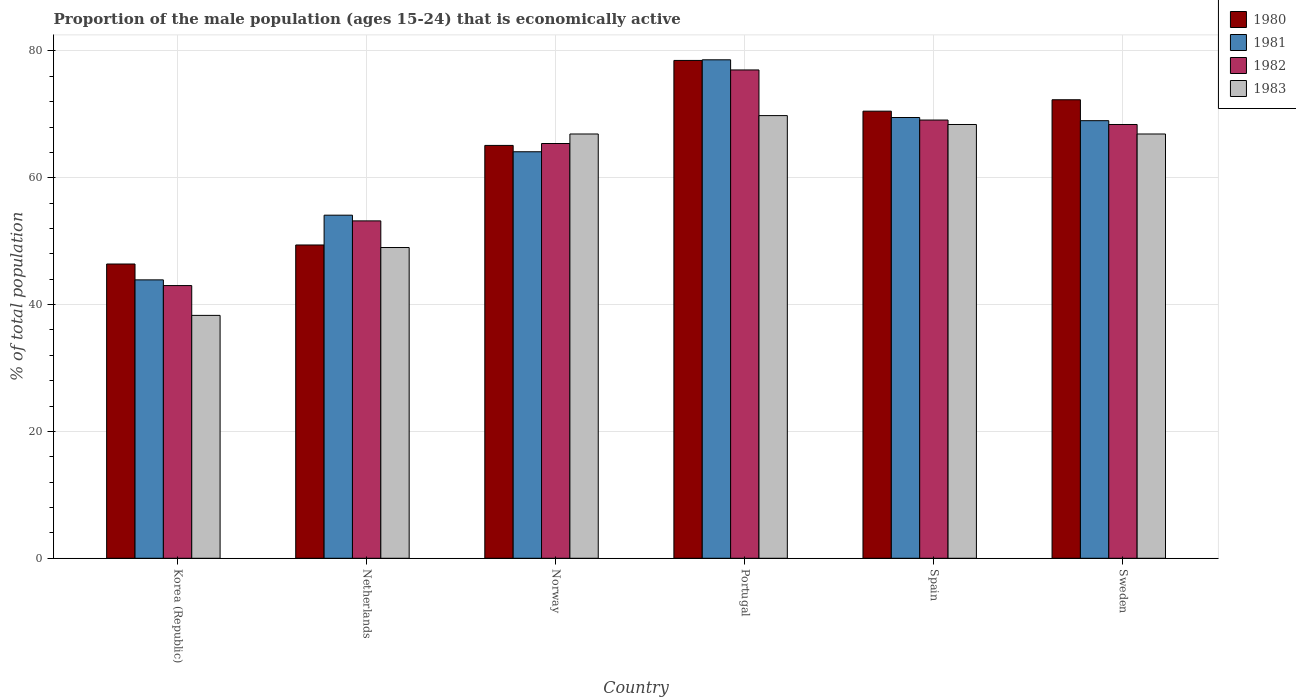How many different coloured bars are there?
Your response must be concise. 4. Are the number of bars on each tick of the X-axis equal?
Ensure brevity in your answer.  Yes. How many bars are there on the 5th tick from the left?
Provide a succinct answer. 4. How many bars are there on the 2nd tick from the right?
Offer a terse response. 4. What is the label of the 5th group of bars from the left?
Your answer should be very brief. Spain. What is the proportion of the male population that is economically active in 1983 in Norway?
Your answer should be compact. 66.9. Across all countries, what is the maximum proportion of the male population that is economically active in 1981?
Provide a short and direct response. 78.6. Across all countries, what is the minimum proportion of the male population that is economically active in 1980?
Offer a very short reply. 46.4. What is the total proportion of the male population that is economically active in 1982 in the graph?
Provide a succinct answer. 376.1. What is the difference between the proportion of the male population that is economically active in 1982 in Spain and that in Sweden?
Offer a very short reply. 0.7. What is the average proportion of the male population that is economically active in 1980 per country?
Your response must be concise. 63.7. What is the difference between the proportion of the male population that is economically active of/in 1981 and proportion of the male population that is economically active of/in 1982 in Portugal?
Provide a short and direct response. 1.6. What is the ratio of the proportion of the male population that is economically active in 1980 in Netherlands to that in Norway?
Your answer should be very brief. 0.76. What is the difference between the highest and the second highest proportion of the male population that is economically active in 1980?
Offer a terse response. 1.8. What is the difference between the highest and the lowest proportion of the male population that is economically active in 1982?
Your answer should be compact. 34. Is the sum of the proportion of the male population that is economically active in 1980 in Netherlands and Spain greater than the maximum proportion of the male population that is economically active in 1983 across all countries?
Keep it short and to the point. Yes. Is it the case that in every country, the sum of the proportion of the male population that is economically active in 1980 and proportion of the male population that is economically active in 1982 is greater than the sum of proportion of the male population that is economically active in 1983 and proportion of the male population that is economically active in 1981?
Make the answer very short. No. What does the 4th bar from the right in Portugal represents?
Ensure brevity in your answer.  1980. Is it the case that in every country, the sum of the proportion of the male population that is economically active in 1983 and proportion of the male population that is economically active in 1981 is greater than the proportion of the male population that is economically active in 1980?
Your answer should be very brief. Yes. How many bars are there?
Your answer should be very brief. 24. Are all the bars in the graph horizontal?
Keep it short and to the point. No. How many countries are there in the graph?
Give a very brief answer. 6. What is the difference between two consecutive major ticks on the Y-axis?
Your response must be concise. 20. What is the title of the graph?
Give a very brief answer. Proportion of the male population (ages 15-24) that is economically active. What is the label or title of the X-axis?
Make the answer very short. Country. What is the label or title of the Y-axis?
Provide a succinct answer. % of total population. What is the % of total population of 1980 in Korea (Republic)?
Offer a very short reply. 46.4. What is the % of total population of 1981 in Korea (Republic)?
Ensure brevity in your answer.  43.9. What is the % of total population of 1983 in Korea (Republic)?
Make the answer very short. 38.3. What is the % of total population of 1980 in Netherlands?
Provide a short and direct response. 49.4. What is the % of total population of 1981 in Netherlands?
Make the answer very short. 54.1. What is the % of total population of 1982 in Netherlands?
Your response must be concise. 53.2. What is the % of total population in 1980 in Norway?
Ensure brevity in your answer.  65.1. What is the % of total population of 1981 in Norway?
Your response must be concise. 64.1. What is the % of total population in 1982 in Norway?
Your answer should be very brief. 65.4. What is the % of total population in 1983 in Norway?
Provide a short and direct response. 66.9. What is the % of total population of 1980 in Portugal?
Keep it short and to the point. 78.5. What is the % of total population of 1981 in Portugal?
Offer a terse response. 78.6. What is the % of total population of 1983 in Portugal?
Make the answer very short. 69.8. What is the % of total population of 1980 in Spain?
Give a very brief answer. 70.5. What is the % of total population in 1981 in Spain?
Ensure brevity in your answer.  69.5. What is the % of total population of 1982 in Spain?
Your answer should be compact. 69.1. What is the % of total population in 1983 in Spain?
Offer a terse response. 68.4. What is the % of total population in 1980 in Sweden?
Provide a succinct answer. 72.3. What is the % of total population of 1981 in Sweden?
Give a very brief answer. 69. What is the % of total population of 1982 in Sweden?
Offer a terse response. 68.4. What is the % of total population of 1983 in Sweden?
Offer a terse response. 66.9. Across all countries, what is the maximum % of total population in 1980?
Ensure brevity in your answer.  78.5. Across all countries, what is the maximum % of total population in 1981?
Keep it short and to the point. 78.6. Across all countries, what is the maximum % of total population of 1982?
Keep it short and to the point. 77. Across all countries, what is the maximum % of total population in 1983?
Offer a very short reply. 69.8. Across all countries, what is the minimum % of total population in 1980?
Keep it short and to the point. 46.4. Across all countries, what is the minimum % of total population of 1981?
Your response must be concise. 43.9. Across all countries, what is the minimum % of total population of 1982?
Your response must be concise. 43. Across all countries, what is the minimum % of total population of 1983?
Provide a short and direct response. 38.3. What is the total % of total population of 1980 in the graph?
Give a very brief answer. 382.2. What is the total % of total population of 1981 in the graph?
Offer a terse response. 379.2. What is the total % of total population in 1982 in the graph?
Your answer should be very brief. 376.1. What is the total % of total population of 1983 in the graph?
Provide a succinct answer. 359.3. What is the difference between the % of total population in 1980 in Korea (Republic) and that in Netherlands?
Give a very brief answer. -3. What is the difference between the % of total population in 1981 in Korea (Republic) and that in Netherlands?
Give a very brief answer. -10.2. What is the difference between the % of total population of 1983 in Korea (Republic) and that in Netherlands?
Provide a succinct answer. -10.7. What is the difference between the % of total population of 1980 in Korea (Republic) and that in Norway?
Provide a succinct answer. -18.7. What is the difference between the % of total population in 1981 in Korea (Republic) and that in Norway?
Provide a short and direct response. -20.2. What is the difference between the % of total population in 1982 in Korea (Republic) and that in Norway?
Your answer should be very brief. -22.4. What is the difference between the % of total population of 1983 in Korea (Republic) and that in Norway?
Provide a short and direct response. -28.6. What is the difference between the % of total population of 1980 in Korea (Republic) and that in Portugal?
Your answer should be compact. -32.1. What is the difference between the % of total population of 1981 in Korea (Republic) and that in Portugal?
Offer a terse response. -34.7. What is the difference between the % of total population of 1982 in Korea (Republic) and that in Portugal?
Ensure brevity in your answer.  -34. What is the difference between the % of total population in 1983 in Korea (Republic) and that in Portugal?
Ensure brevity in your answer.  -31.5. What is the difference between the % of total population in 1980 in Korea (Republic) and that in Spain?
Keep it short and to the point. -24.1. What is the difference between the % of total population of 1981 in Korea (Republic) and that in Spain?
Your response must be concise. -25.6. What is the difference between the % of total population of 1982 in Korea (Republic) and that in Spain?
Your response must be concise. -26.1. What is the difference between the % of total population in 1983 in Korea (Republic) and that in Spain?
Provide a short and direct response. -30.1. What is the difference between the % of total population in 1980 in Korea (Republic) and that in Sweden?
Your response must be concise. -25.9. What is the difference between the % of total population of 1981 in Korea (Republic) and that in Sweden?
Provide a succinct answer. -25.1. What is the difference between the % of total population of 1982 in Korea (Republic) and that in Sweden?
Keep it short and to the point. -25.4. What is the difference between the % of total population of 1983 in Korea (Republic) and that in Sweden?
Your answer should be compact. -28.6. What is the difference between the % of total population in 1980 in Netherlands and that in Norway?
Your answer should be very brief. -15.7. What is the difference between the % of total population in 1981 in Netherlands and that in Norway?
Keep it short and to the point. -10. What is the difference between the % of total population in 1982 in Netherlands and that in Norway?
Offer a terse response. -12.2. What is the difference between the % of total population in 1983 in Netherlands and that in Norway?
Ensure brevity in your answer.  -17.9. What is the difference between the % of total population in 1980 in Netherlands and that in Portugal?
Your response must be concise. -29.1. What is the difference between the % of total population of 1981 in Netherlands and that in Portugal?
Make the answer very short. -24.5. What is the difference between the % of total population in 1982 in Netherlands and that in Portugal?
Make the answer very short. -23.8. What is the difference between the % of total population of 1983 in Netherlands and that in Portugal?
Make the answer very short. -20.8. What is the difference between the % of total population of 1980 in Netherlands and that in Spain?
Keep it short and to the point. -21.1. What is the difference between the % of total population in 1981 in Netherlands and that in Spain?
Offer a very short reply. -15.4. What is the difference between the % of total population in 1982 in Netherlands and that in Spain?
Your answer should be very brief. -15.9. What is the difference between the % of total population in 1983 in Netherlands and that in Spain?
Make the answer very short. -19.4. What is the difference between the % of total population of 1980 in Netherlands and that in Sweden?
Your answer should be very brief. -22.9. What is the difference between the % of total population of 1981 in Netherlands and that in Sweden?
Your response must be concise. -14.9. What is the difference between the % of total population in 1982 in Netherlands and that in Sweden?
Provide a short and direct response. -15.2. What is the difference between the % of total population of 1983 in Netherlands and that in Sweden?
Provide a succinct answer. -17.9. What is the difference between the % of total population in 1981 in Norway and that in Portugal?
Make the answer very short. -14.5. What is the difference between the % of total population of 1983 in Norway and that in Portugal?
Offer a terse response. -2.9. What is the difference between the % of total population of 1980 in Norway and that in Spain?
Provide a succinct answer. -5.4. What is the difference between the % of total population of 1981 in Norway and that in Spain?
Provide a short and direct response. -5.4. What is the difference between the % of total population of 1981 in Norway and that in Sweden?
Your answer should be compact. -4.9. What is the difference between the % of total population in 1982 in Norway and that in Sweden?
Provide a short and direct response. -3. What is the difference between the % of total population in 1980 in Portugal and that in Spain?
Your response must be concise. 8. What is the difference between the % of total population in 1981 in Portugal and that in Spain?
Ensure brevity in your answer.  9.1. What is the difference between the % of total population in 1982 in Portugal and that in Spain?
Provide a succinct answer. 7.9. What is the difference between the % of total population of 1982 in Portugal and that in Sweden?
Your answer should be compact. 8.6. What is the difference between the % of total population in 1981 in Korea (Republic) and the % of total population in 1983 in Netherlands?
Ensure brevity in your answer.  -5.1. What is the difference between the % of total population in 1980 in Korea (Republic) and the % of total population in 1981 in Norway?
Make the answer very short. -17.7. What is the difference between the % of total population of 1980 in Korea (Republic) and the % of total population of 1982 in Norway?
Your response must be concise. -19. What is the difference between the % of total population in 1980 in Korea (Republic) and the % of total population in 1983 in Norway?
Provide a succinct answer. -20.5. What is the difference between the % of total population in 1981 in Korea (Republic) and the % of total population in 1982 in Norway?
Offer a very short reply. -21.5. What is the difference between the % of total population in 1982 in Korea (Republic) and the % of total population in 1983 in Norway?
Ensure brevity in your answer.  -23.9. What is the difference between the % of total population of 1980 in Korea (Republic) and the % of total population of 1981 in Portugal?
Keep it short and to the point. -32.2. What is the difference between the % of total population of 1980 in Korea (Republic) and the % of total population of 1982 in Portugal?
Ensure brevity in your answer.  -30.6. What is the difference between the % of total population of 1980 in Korea (Republic) and the % of total population of 1983 in Portugal?
Make the answer very short. -23.4. What is the difference between the % of total population of 1981 in Korea (Republic) and the % of total population of 1982 in Portugal?
Offer a very short reply. -33.1. What is the difference between the % of total population of 1981 in Korea (Republic) and the % of total population of 1983 in Portugal?
Provide a succinct answer. -25.9. What is the difference between the % of total population in 1982 in Korea (Republic) and the % of total population in 1983 in Portugal?
Keep it short and to the point. -26.8. What is the difference between the % of total population in 1980 in Korea (Republic) and the % of total population in 1981 in Spain?
Keep it short and to the point. -23.1. What is the difference between the % of total population in 1980 in Korea (Republic) and the % of total population in 1982 in Spain?
Offer a terse response. -22.7. What is the difference between the % of total population of 1981 in Korea (Republic) and the % of total population of 1982 in Spain?
Give a very brief answer. -25.2. What is the difference between the % of total population of 1981 in Korea (Republic) and the % of total population of 1983 in Spain?
Your response must be concise. -24.5. What is the difference between the % of total population in 1982 in Korea (Republic) and the % of total population in 1983 in Spain?
Ensure brevity in your answer.  -25.4. What is the difference between the % of total population of 1980 in Korea (Republic) and the % of total population of 1981 in Sweden?
Provide a short and direct response. -22.6. What is the difference between the % of total population in 1980 in Korea (Republic) and the % of total population in 1983 in Sweden?
Provide a succinct answer. -20.5. What is the difference between the % of total population of 1981 in Korea (Republic) and the % of total population of 1982 in Sweden?
Keep it short and to the point. -24.5. What is the difference between the % of total population of 1981 in Korea (Republic) and the % of total population of 1983 in Sweden?
Provide a succinct answer. -23. What is the difference between the % of total population in 1982 in Korea (Republic) and the % of total population in 1983 in Sweden?
Give a very brief answer. -23.9. What is the difference between the % of total population of 1980 in Netherlands and the % of total population of 1981 in Norway?
Provide a succinct answer. -14.7. What is the difference between the % of total population in 1980 in Netherlands and the % of total population in 1982 in Norway?
Keep it short and to the point. -16. What is the difference between the % of total population of 1980 in Netherlands and the % of total population of 1983 in Norway?
Offer a terse response. -17.5. What is the difference between the % of total population in 1981 in Netherlands and the % of total population in 1982 in Norway?
Ensure brevity in your answer.  -11.3. What is the difference between the % of total population of 1982 in Netherlands and the % of total population of 1983 in Norway?
Your response must be concise. -13.7. What is the difference between the % of total population of 1980 in Netherlands and the % of total population of 1981 in Portugal?
Make the answer very short. -29.2. What is the difference between the % of total population of 1980 in Netherlands and the % of total population of 1982 in Portugal?
Your response must be concise. -27.6. What is the difference between the % of total population of 1980 in Netherlands and the % of total population of 1983 in Portugal?
Ensure brevity in your answer.  -20.4. What is the difference between the % of total population of 1981 in Netherlands and the % of total population of 1982 in Portugal?
Make the answer very short. -22.9. What is the difference between the % of total population of 1981 in Netherlands and the % of total population of 1983 in Portugal?
Provide a succinct answer. -15.7. What is the difference between the % of total population in 1982 in Netherlands and the % of total population in 1983 in Portugal?
Provide a succinct answer. -16.6. What is the difference between the % of total population in 1980 in Netherlands and the % of total population in 1981 in Spain?
Your answer should be compact. -20.1. What is the difference between the % of total population in 1980 in Netherlands and the % of total population in 1982 in Spain?
Offer a terse response. -19.7. What is the difference between the % of total population of 1981 in Netherlands and the % of total population of 1983 in Spain?
Provide a short and direct response. -14.3. What is the difference between the % of total population in 1982 in Netherlands and the % of total population in 1983 in Spain?
Your response must be concise. -15.2. What is the difference between the % of total population of 1980 in Netherlands and the % of total population of 1981 in Sweden?
Offer a very short reply. -19.6. What is the difference between the % of total population in 1980 in Netherlands and the % of total population in 1982 in Sweden?
Keep it short and to the point. -19. What is the difference between the % of total population in 1980 in Netherlands and the % of total population in 1983 in Sweden?
Give a very brief answer. -17.5. What is the difference between the % of total population in 1981 in Netherlands and the % of total population in 1982 in Sweden?
Your response must be concise. -14.3. What is the difference between the % of total population of 1982 in Netherlands and the % of total population of 1983 in Sweden?
Give a very brief answer. -13.7. What is the difference between the % of total population of 1980 in Norway and the % of total population of 1981 in Portugal?
Offer a very short reply. -13.5. What is the difference between the % of total population of 1980 in Norway and the % of total population of 1982 in Portugal?
Provide a succinct answer. -11.9. What is the difference between the % of total population in 1982 in Norway and the % of total population in 1983 in Portugal?
Offer a terse response. -4.4. What is the difference between the % of total population in 1980 in Norway and the % of total population in 1981 in Spain?
Your response must be concise. -4.4. What is the difference between the % of total population of 1980 in Norway and the % of total population of 1982 in Spain?
Provide a short and direct response. -4. What is the difference between the % of total population of 1980 in Norway and the % of total population of 1983 in Spain?
Make the answer very short. -3.3. What is the difference between the % of total population of 1981 in Norway and the % of total population of 1983 in Spain?
Offer a very short reply. -4.3. What is the difference between the % of total population of 1980 in Norway and the % of total population of 1981 in Sweden?
Give a very brief answer. -3.9. What is the difference between the % of total population in 1980 in Norway and the % of total population in 1982 in Sweden?
Your response must be concise. -3.3. What is the difference between the % of total population of 1981 in Norway and the % of total population of 1982 in Sweden?
Provide a succinct answer. -4.3. What is the difference between the % of total population in 1981 in Norway and the % of total population in 1983 in Sweden?
Your response must be concise. -2.8. What is the difference between the % of total population of 1982 in Norway and the % of total population of 1983 in Sweden?
Make the answer very short. -1.5. What is the difference between the % of total population in 1981 in Portugal and the % of total population in 1982 in Spain?
Ensure brevity in your answer.  9.5. What is the difference between the % of total population in 1981 in Portugal and the % of total population in 1983 in Spain?
Give a very brief answer. 10.2. What is the difference between the % of total population in 1982 in Portugal and the % of total population in 1983 in Spain?
Your response must be concise. 8.6. What is the difference between the % of total population in 1980 in Portugal and the % of total population in 1981 in Sweden?
Your response must be concise. 9.5. What is the difference between the % of total population of 1980 in Portugal and the % of total population of 1982 in Sweden?
Offer a very short reply. 10.1. What is the difference between the % of total population of 1980 in Portugal and the % of total population of 1983 in Sweden?
Offer a terse response. 11.6. What is the difference between the % of total population of 1981 in Portugal and the % of total population of 1983 in Sweden?
Offer a terse response. 11.7. What is the difference between the % of total population in 1981 in Spain and the % of total population in 1983 in Sweden?
Your answer should be very brief. 2.6. What is the average % of total population of 1980 per country?
Provide a succinct answer. 63.7. What is the average % of total population of 1981 per country?
Make the answer very short. 63.2. What is the average % of total population of 1982 per country?
Give a very brief answer. 62.68. What is the average % of total population in 1983 per country?
Ensure brevity in your answer.  59.88. What is the difference between the % of total population of 1981 and % of total population of 1982 in Korea (Republic)?
Your answer should be very brief. 0.9. What is the difference between the % of total population in 1980 and % of total population in 1981 in Netherlands?
Your answer should be very brief. -4.7. What is the difference between the % of total population in 1980 and % of total population in 1983 in Netherlands?
Provide a short and direct response. 0.4. What is the difference between the % of total population in 1981 and % of total population in 1982 in Netherlands?
Provide a short and direct response. 0.9. What is the difference between the % of total population of 1981 and % of total population of 1983 in Netherlands?
Provide a short and direct response. 5.1. What is the difference between the % of total population of 1980 and % of total population of 1981 in Norway?
Make the answer very short. 1. What is the difference between the % of total population in 1980 and % of total population in 1982 in Norway?
Offer a terse response. -0.3. What is the difference between the % of total population in 1981 and % of total population in 1983 in Norway?
Your answer should be compact. -2.8. What is the difference between the % of total population in 1981 and % of total population in 1982 in Spain?
Your response must be concise. 0.4. What is the difference between the % of total population of 1981 and % of total population of 1983 in Spain?
Your answer should be compact. 1.1. What is the difference between the % of total population in 1980 and % of total population in 1982 in Sweden?
Offer a terse response. 3.9. What is the ratio of the % of total population of 1980 in Korea (Republic) to that in Netherlands?
Your answer should be compact. 0.94. What is the ratio of the % of total population in 1981 in Korea (Republic) to that in Netherlands?
Offer a terse response. 0.81. What is the ratio of the % of total population of 1982 in Korea (Republic) to that in Netherlands?
Your answer should be very brief. 0.81. What is the ratio of the % of total population in 1983 in Korea (Republic) to that in Netherlands?
Give a very brief answer. 0.78. What is the ratio of the % of total population of 1980 in Korea (Republic) to that in Norway?
Ensure brevity in your answer.  0.71. What is the ratio of the % of total population of 1981 in Korea (Republic) to that in Norway?
Your answer should be compact. 0.68. What is the ratio of the % of total population of 1982 in Korea (Republic) to that in Norway?
Provide a succinct answer. 0.66. What is the ratio of the % of total population in 1983 in Korea (Republic) to that in Norway?
Provide a succinct answer. 0.57. What is the ratio of the % of total population of 1980 in Korea (Republic) to that in Portugal?
Ensure brevity in your answer.  0.59. What is the ratio of the % of total population in 1981 in Korea (Republic) to that in Portugal?
Offer a very short reply. 0.56. What is the ratio of the % of total population of 1982 in Korea (Republic) to that in Portugal?
Provide a succinct answer. 0.56. What is the ratio of the % of total population of 1983 in Korea (Republic) to that in Portugal?
Provide a succinct answer. 0.55. What is the ratio of the % of total population of 1980 in Korea (Republic) to that in Spain?
Your answer should be compact. 0.66. What is the ratio of the % of total population in 1981 in Korea (Republic) to that in Spain?
Ensure brevity in your answer.  0.63. What is the ratio of the % of total population of 1982 in Korea (Republic) to that in Spain?
Provide a short and direct response. 0.62. What is the ratio of the % of total population in 1983 in Korea (Republic) to that in Spain?
Your answer should be very brief. 0.56. What is the ratio of the % of total population of 1980 in Korea (Republic) to that in Sweden?
Make the answer very short. 0.64. What is the ratio of the % of total population of 1981 in Korea (Republic) to that in Sweden?
Offer a very short reply. 0.64. What is the ratio of the % of total population of 1982 in Korea (Republic) to that in Sweden?
Your response must be concise. 0.63. What is the ratio of the % of total population in 1983 in Korea (Republic) to that in Sweden?
Your answer should be compact. 0.57. What is the ratio of the % of total population of 1980 in Netherlands to that in Norway?
Offer a very short reply. 0.76. What is the ratio of the % of total population in 1981 in Netherlands to that in Norway?
Make the answer very short. 0.84. What is the ratio of the % of total population of 1982 in Netherlands to that in Norway?
Offer a very short reply. 0.81. What is the ratio of the % of total population of 1983 in Netherlands to that in Norway?
Your answer should be compact. 0.73. What is the ratio of the % of total population of 1980 in Netherlands to that in Portugal?
Provide a short and direct response. 0.63. What is the ratio of the % of total population in 1981 in Netherlands to that in Portugal?
Offer a terse response. 0.69. What is the ratio of the % of total population of 1982 in Netherlands to that in Portugal?
Provide a succinct answer. 0.69. What is the ratio of the % of total population in 1983 in Netherlands to that in Portugal?
Provide a short and direct response. 0.7. What is the ratio of the % of total population in 1980 in Netherlands to that in Spain?
Provide a succinct answer. 0.7. What is the ratio of the % of total population in 1981 in Netherlands to that in Spain?
Keep it short and to the point. 0.78. What is the ratio of the % of total population in 1982 in Netherlands to that in Spain?
Your answer should be compact. 0.77. What is the ratio of the % of total population of 1983 in Netherlands to that in Spain?
Offer a terse response. 0.72. What is the ratio of the % of total population in 1980 in Netherlands to that in Sweden?
Offer a very short reply. 0.68. What is the ratio of the % of total population of 1981 in Netherlands to that in Sweden?
Your answer should be compact. 0.78. What is the ratio of the % of total population of 1982 in Netherlands to that in Sweden?
Make the answer very short. 0.78. What is the ratio of the % of total population in 1983 in Netherlands to that in Sweden?
Provide a short and direct response. 0.73. What is the ratio of the % of total population in 1980 in Norway to that in Portugal?
Provide a succinct answer. 0.83. What is the ratio of the % of total population of 1981 in Norway to that in Portugal?
Provide a short and direct response. 0.82. What is the ratio of the % of total population in 1982 in Norway to that in Portugal?
Ensure brevity in your answer.  0.85. What is the ratio of the % of total population of 1983 in Norway to that in Portugal?
Give a very brief answer. 0.96. What is the ratio of the % of total population of 1980 in Norway to that in Spain?
Keep it short and to the point. 0.92. What is the ratio of the % of total population of 1981 in Norway to that in Spain?
Your answer should be very brief. 0.92. What is the ratio of the % of total population in 1982 in Norway to that in Spain?
Give a very brief answer. 0.95. What is the ratio of the % of total population in 1983 in Norway to that in Spain?
Give a very brief answer. 0.98. What is the ratio of the % of total population in 1980 in Norway to that in Sweden?
Keep it short and to the point. 0.9. What is the ratio of the % of total population in 1981 in Norway to that in Sweden?
Your answer should be very brief. 0.93. What is the ratio of the % of total population of 1982 in Norway to that in Sweden?
Offer a very short reply. 0.96. What is the ratio of the % of total population of 1980 in Portugal to that in Spain?
Keep it short and to the point. 1.11. What is the ratio of the % of total population of 1981 in Portugal to that in Spain?
Your answer should be very brief. 1.13. What is the ratio of the % of total population of 1982 in Portugal to that in Spain?
Offer a terse response. 1.11. What is the ratio of the % of total population in 1983 in Portugal to that in Spain?
Offer a terse response. 1.02. What is the ratio of the % of total population of 1980 in Portugal to that in Sweden?
Provide a succinct answer. 1.09. What is the ratio of the % of total population in 1981 in Portugal to that in Sweden?
Give a very brief answer. 1.14. What is the ratio of the % of total population of 1982 in Portugal to that in Sweden?
Ensure brevity in your answer.  1.13. What is the ratio of the % of total population in 1983 in Portugal to that in Sweden?
Your response must be concise. 1.04. What is the ratio of the % of total population in 1980 in Spain to that in Sweden?
Offer a very short reply. 0.98. What is the ratio of the % of total population in 1981 in Spain to that in Sweden?
Offer a very short reply. 1.01. What is the ratio of the % of total population of 1982 in Spain to that in Sweden?
Your answer should be very brief. 1.01. What is the ratio of the % of total population in 1983 in Spain to that in Sweden?
Keep it short and to the point. 1.02. What is the difference between the highest and the second highest % of total population in 1980?
Offer a terse response. 6.2. What is the difference between the highest and the second highest % of total population in 1981?
Give a very brief answer. 9.1. What is the difference between the highest and the second highest % of total population of 1983?
Ensure brevity in your answer.  1.4. What is the difference between the highest and the lowest % of total population in 1980?
Provide a short and direct response. 32.1. What is the difference between the highest and the lowest % of total population in 1981?
Your answer should be very brief. 34.7. What is the difference between the highest and the lowest % of total population of 1983?
Your answer should be compact. 31.5. 